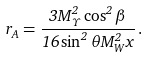<formula> <loc_0><loc_0><loc_500><loc_500>r _ { A } = \frac { 3 M _ { \Upsilon } ^ { 2 } \cos ^ { 2 } \beta } { 1 6 \sin ^ { 2 } \theta M _ { W } ^ { 2 } x } \, .</formula> 